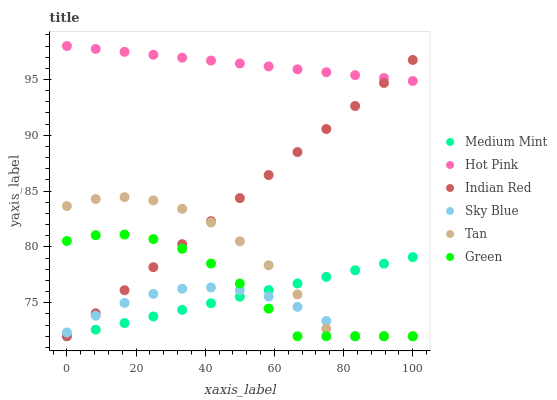Does Sky Blue have the minimum area under the curve?
Answer yes or no. Yes. Does Hot Pink have the maximum area under the curve?
Answer yes or no. Yes. Does Green have the minimum area under the curve?
Answer yes or no. No. Does Green have the maximum area under the curve?
Answer yes or no. No. Is Indian Red the smoothest?
Answer yes or no. Yes. Is Tan the roughest?
Answer yes or no. Yes. Is Hot Pink the smoothest?
Answer yes or no. No. Is Hot Pink the roughest?
Answer yes or no. No. Does Medium Mint have the lowest value?
Answer yes or no. Yes. Does Hot Pink have the lowest value?
Answer yes or no. No. Does Hot Pink have the highest value?
Answer yes or no. Yes. Does Green have the highest value?
Answer yes or no. No. Is Medium Mint less than Hot Pink?
Answer yes or no. Yes. Is Hot Pink greater than Sky Blue?
Answer yes or no. Yes. Does Tan intersect Sky Blue?
Answer yes or no. Yes. Is Tan less than Sky Blue?
Answer yes or no. No. Is Tan greater than Sky Blue?
Answer yes or no. No. Does Medium Mint intersect Hot Pink?
Answer yes or no. No. 